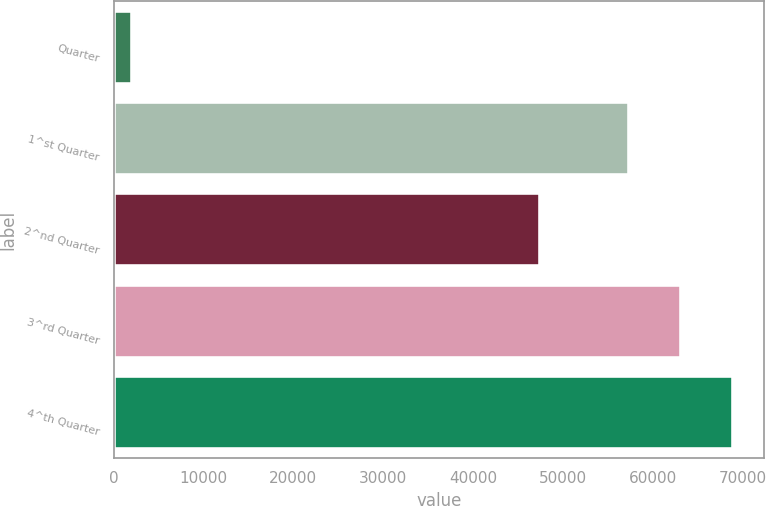Convert chart. <chart><loc_0><loc_0><loc_500><loc_500><bar_chart><fcel>Quarter<fcel>1^st Quarter<fcel>2^nd Quarter<fcel>3^rd Quarter<fcel>4^th Quarter<nl><fcel>2012<fcel>57400<fcel>47500<fcel>63178.8<fcel>68957.6<nl></chart> 